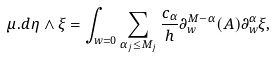Convert formula to latex. <formula><loc_0><loc_0><loc_500><loc_500>\mu . d \eta \wedge \xi = \int _ { w = 0 } \sum _ { \alpha _ { j } \leq M _ { j } } \frac { c _ { \alpha } } { h } \partial _ { w } ^ { M - \alpha } ( A ) \partial _ { w } ^ { \alpha } \xi ,</formula> 